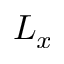<formula> <loc_0><loc_0><loc_500><loc_500>L _ { x }</formula> 